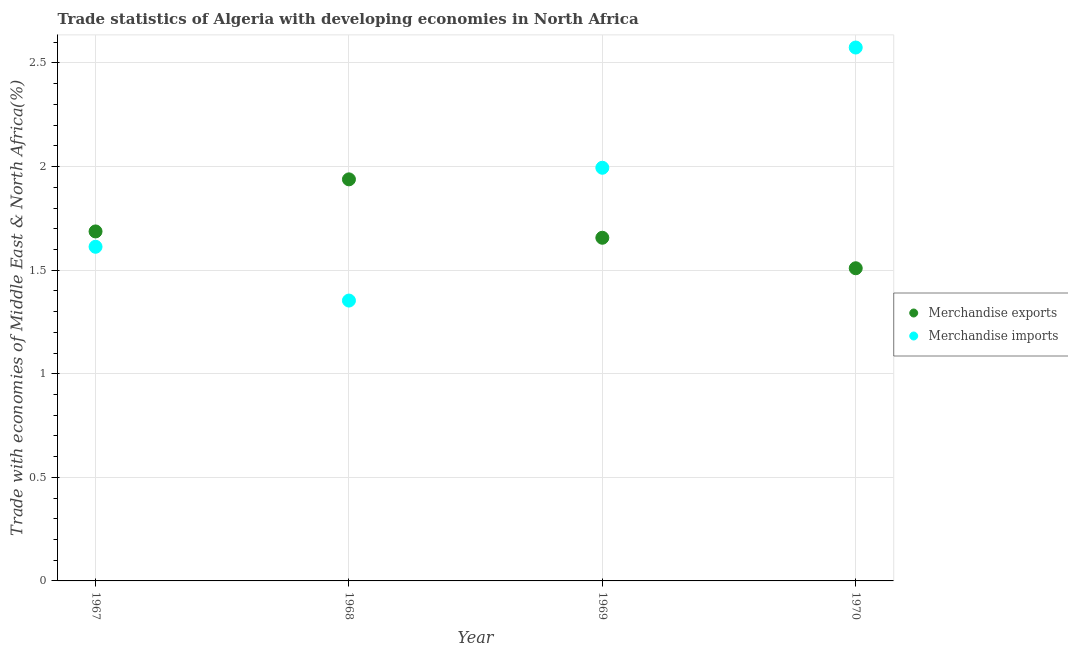How many different coloured dotlines are there?
Ensure brevity in your answer.  2. Is the number of dotlines equal to the number of legend labels?
Provide a succinct answer. Yes. What is the merchandise imports in 1969?
Give a very brief answer. 1.99. Across all years, what is the maximum merchandise imports?
Your answer should be compact. 2.57. Across all years, what is the minimum merchandise exports?
Keep it short and to the point. 1.51. In which year was the merchandise exports maximum?
Ensure brevity in your answer.  1968. In which year was the merchandise exports minimum?
Your answer should be very brief. 1970. What is the total merchandise exports in the graph?
Give a very brief answer. 6.79. What is the difference between the merchandise exports in 1969 and that in 1970?
Your answer should be compact. 0.15. What is the difference between the merchandise exports in 1969 and the merchandise imports in 1967?
Keep it short and to the point. 0.04. What is the average merchandise imports per year?
Your answer should be compact. 1.88. In the year 1970, what is the difference between the merchandise exports and merchandise imports?
Offer a terse response. -1.07. In how many years, is the merchandise imports greater than 1.7 %?
Make the answer very short. 2. What is the ratio of the merchandise exports in 1968 to that in 1969?
Offer a very short reply. 1.17. Is the merchandise exports in 1967 less than that in 1968?
Keep it short and to the point. Yes. Is the difference between the merchandise imports in 1969 and 1970 greater than the difference between the merchandise exports in 1969 and 1970?
Give a very brief answer. No. What is the difference between the highest and the second highest merchandise exports?
Ensure brevity in your answer.  0.25. What is the difference between the highest and the lowest merchandise imports?
Offer a very short reply. 1.22. Is the sum of the merchandise imports in 1967 and 1968 greater than the maximum merchandise exports across all years?
Provide a succinct answer. Yes. Does the merchandise imports monotonically increase over the years?
Provide a succinct answer. No. Is the merchandise imports strictly less than the merchandise exports over the years?
Offer a very short reply. No. How many dotlines are there?
Your answer should be compact. 2. How many years are there in the graph?
Your response must be concise. 4. What is the difference between two consecutive major ticks on the Y-axis?
Offer a very short reply. 0.5. Where does the legend appear in the graph?
Provide a short and direct response. Center right. How many legend labels are there?
Offer a terse response. 2. What is the title of the graph?
Provide a short and direct response. Trade statistics of Algeria with developing economies in North Africa. Does "Canada" appear as one of the legend labels in the graph?
Offer a very short reply. No. What is the label or title of the Y-axis?
Your answer should be compact. Trade with economies of Middle East & North Africa(%). What is the Trade with economies of Middle East & North Africa(%) in Merchandise exports in 1967?
Make the answer very short. 1.69. What is the Trade with economies of Middle East & North Africa(%) in Merchandise imports in 1967?
Keep it short and to the point. 1.61. What is the Trade with economies of Middle East & North Africa(%) of Merchandise exports in 1968?
Offer a very short reply. 1.94. What is the Trade with economies of Middle East & North Africa(%) in Merchandise imports in 1968?
Provide a succinct answer. 1.35. What is the Trade with economies of Middle East & North Africa(%) of Merchandise exports in 1969?
Provide a short and direct response. 1.66. What is the Trade with economies of Middle East & North Africa(%) of Merchandise imports in 1969?
Ensure brevity in your answer.  1.99. What is the Trade with economies of Middle East & North Africa(%) of Merchandise exports in 1970?
Offer a terse response. 1.51. What is the Trade with economies of Middle East & North Africa(%) in Merchandise imports in 1970?
Make the answer very short. 2.57. Across all years, what is the maximum Trade with economies of Middle East & North Africa(%) of Merchandise exports?
Make the answer very short. 1.94. Across all years, what is the maximum Trade with economies of Middle East & North Africa(%) in Merchandise imports?
Keep it short and to the point. 2.57. Across all years, what is the minimum Trade with economies of Middle East & North Africa(%) in Merchandise exports?
Offer a very short reply. 1.51. Across all years, what is the minimum Trade with economies of Middle East & North Africa(%) in Merchandise imports?
Make the answer very short. 1.35. What is the total Trade with economies of Middle East & North Africa(%) in Merchandise exports in the graph?
Give a very brief answer. 6.79. What is the total Trade with economies of Middle East & North Africa(%) in Merchandise imports in the graph?
Provide a short and direct response. 7.54. What is the difference between the Trade with economies of Middle East & North Africa(%) of Merchandise exports in 1967 and that in 1968?
Offer a very short reply. -0.25. What is the difference between the Trade with economies of Middle East & North Africa(%) in Merchandise imports in 1967 and that in 1968?
Your answer should be very brief. 0.26. What is the difference between the Trade with economies of Middle East & North Africa(%) of Merchandise exports in 1967 and that in 1969?
Provide a succinct answer. 0.03. What is the difference between the Trade with economies of Middle East & North Africa(%) in Merchandise imports in 1967 and that in 1969?
Your answer should be very brief. -0.38. What is the difference between the Trade with economies of Middle East & North Africa(%) in Merchandise exports in 1967 and that in 1970?
Your answer should be very brief. 0.18. What is the difference between the Trade with economies of Middle East & North Africa(%) in Merchandise imports in 1967 and that in 1970?
Offer a terse response. -0.96. What is the difference between the Trade with economies of Middle East & North Africa(%) in Merchandise exports in 1968 and that in 1969?
Ensure brevity in your answer.  0.28. What is the difference between the Trade with economies of Middle East & North Africa(%) of Merchandise imports in 1968 and that in 1969?
Make the answer very short. -0.64. What is the difference between the Trade with economies of Middle East & North Africa(%) in Merchandise exports in 1968 and that in 1970?
Make the answer very short. 0.43. What is the difference between the Trade with economies of Middle East & North Africa(%) of Merchandise imports in 1968 and that in 1970?
Provide a succinct answer. -1.22. What is the difference between the Trade with economies of Middle East & North Africa(%) in Merchandise exports in 1969 and that in 1970?
Keep it short and to the point. 0.15. What is the difference between the Trade with economies of Middle East & North Africa(%) in Merchandise imports in 1969 and that in 1970?
Provide a succinct answer. -0.58. What is the difference between the Trade with economies of Middle East & North Africa(%) of Merchandise exports in 1967 and the Trade with economies of Middle East & North Africa(%) of Merchandise imports in 1968?
Provide a succinct answer. 0.33. What is the difference between the Trade with economies of Middle East & North Africa(%) of Merchandise exports in 1967 and the Trade with economies of Middle East & North Africa(%) of Merchandise imports in 1969?
Give a very brief answer. -0.31. What is the difference between the Trade with economies of Middle East & North Africa(%) of Merchandise exports in 1967 and the Trade with economies of Middle East & North Africa(%) of Merchandise imports in 1970?
Provide a succinct answer. -0.89. What is the difference between the Trade with economies of Middle East & North Africa(%) in Merchandise exports in 1968 and the Trade with economies of Middle East & North Africa(%) in Merchandise imports in 1969?
Offer a terse response. -0.06. What is the difference between the Trade with economies of Middle East & North Africa(%) in Merchandise exports in 1968 and the Trade with economies of Middle East & North Africa(%) in Merchandise imports in 1970?
Give a very brief answer. -0.64. What is the difference between the Trade with economies of Middle East & North Africa(%) of Merchandise exports in 1969 and the Trade with economies of Middle East & North Africa(%) of Merchandise imports in 1970?
Give a very brief answer. -0.92. What is the average Trade with economies of Middle East & North Africa(%) of Merchandise exports per year?
Your answer should be compact. 1.7. What is the average Trade with economies of Middle East & North Africa(%) of Merchandise imports per year?
Offer a very short reply. 1.88. In the year 1967, what is the difference between the Trade with economies of Middle East & North Africa(%) in Merchandise exports and Trade with economies of Middle East & North Africa(%) in Merchandise imports?
Keep it short and to the point. 0.07. In the year 1968, what is the difference between the Trade with economies of Middle East & North Africa(%) in Merchandise exports and Trade with economies of Middle East & North Africa(%) in Merchandise imports?
Ensure brevity in your answer.  0.59. In the year 1969, what is the difference between the Trade with economies of Middle East & North Africa(%) of Merchandise exports and Trade with economies of Middle East & North Africa(%) of Merchandise imports?
Your answer should be very brief. -0.34. In the year 1970, what is the difference between the Trade with economies of Middle East & North Africa(%) in Merchandise exports and Trade with economies of Middle East & North Africa(%) in Merchandise imports?
Provide a succinct answer. -1.07. What is the ratio of the Trade with economies of Middle East & North Africa(%) of Merchandise exports in 1967 to that in 1968?
Your answer should be very brief. 0.87. What is the ratio of the Trade with economies of Middle East & North Africa(%) in Merchandise imports in 1967 to that in 1968?
Make the answer very short. 1.19. What is the ratio of the Trade with economies of Middle East & North Africa(%) of Merchandise exports in 1967 to that in 1969?
Provide a succinct answer. 1.02. What is the ratio of the Trade with economies of Middle East & North Africa(%) of Merchandise imports in 1967 to that in 1969?
Provide a short and direct response. 0.81. What is the ratio of the Trade with economies of Middle East & North Africa(%) of Merchandise exports in 1967 to that in 1970?
Your response must be concise. 1.12. What is the ratio of the Trade with economies of Middle East & North Africa(%) in Merchandise imports in 1967 to that in 1970?
Give a very brief answer. 0.63. What is the ratio of the Trade with economies of Middle East & North Africa(%) in Merchandise exports in 1968 to that in 1969?
Your answer should be very brief. 1.17. What is the ratio of the Trade with economies of Middle East & North Africa(%) of Merchandise imports in 1968 to that in 1969?
Offer a terse response. 0.68. What is the ratio of the Trade with economies of Middle East & North Africa(%) of Merchandise exports in 1968 to that in 1970?
Your response must be concise. 1.28. What is the ratio of the Trade with economies of Middle East & North Africa(%) of Merchandise imports in 1968 to that in 1970?
Ensure brevity in your answer.  0.53. What is the ratio of the Trade with economies of Middle East & North Africa(%) of Merchandise exports in 1969 to that in 1970?
Your answer should be compact. 1.1. What is the ratio of the Trade with economies of Middle East & North Africa(%) in Merchandise imports in 1969 to that in 1970?
Offer a terse response. 0.77. What is the difference between the highest and the second highest Trade with economies of Middle East & North Africa(%) in Merchandise exports?
Ensure brevity in your answer.  0.25. What is the difference between the highest and the second highest Trade with economies of Middle East & North Africa(%) in Merchandise imports?
Your answer should be very brief. 0.58. What is the difference between the highest and the lowest Trade with economies of Middle East & North Africa(%) in Merchandise exports?
Give a very brief answer. 0.43. What is the difference between the highest and the lowest Trade with economies of Middle East & North Africa(%) in Merchandise imports?
Offer a terse response. 1.22. 